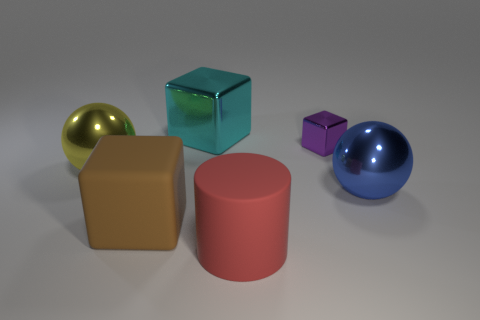Add 1 red rubber cylinders. How many objects exist? 7 Subtract all cylinders. How many objects are left? 5 Subtract 1 cyan cubes. How many objects are left? 5 Subtract all gray balls. Subtract all brown objects. How many objects are left? 5 Add 1 metal balls. How many metal balls are left? 3 Add 1 large yellow objects. How many large yellow objects exist? 2 